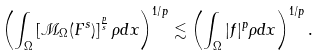Convert formula to latex. <formula><loc_0><loc_0><loc_500><loc_500>\left ( \int _ { \Omega } \left [ \mathcal { M } _ { \Omega } ( F ^ { s } ) \right ] ^ { \frac { p } { s } } \rho d x \right ) ^ { 1 / p } \lesssim \left ( \int _ { \Omega } | f | ^ { p } \rho d x \right ) ^ { 1 / p } .</formula> 